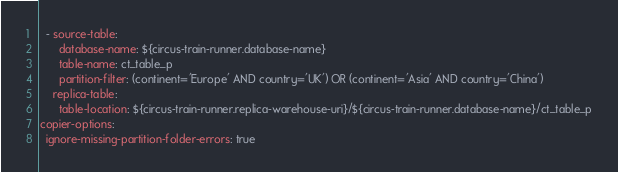Convert code to text. <code><loc_0><loc_0><loc_500><loc_500><_YAML_>  - source-table:
      database-name: ${circus-train-runner.database-name}
      table-name: ct_table_p
      partition-filter: (continent='Europe' AND country='UK') OR (continent='Asia' AND country='China')
    replica-table:
      table-location: ${circus-train-runner.replica-warehouse-uri}/${circus-train-runner.database-name}/ct_table_p
copier-options:
  ignore-missing-partition-folder-errors: true
</code> 